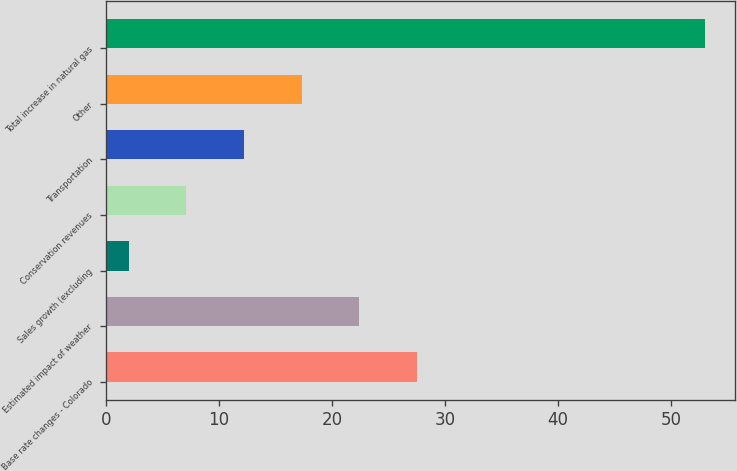Convert chart to OTSL. <chart><loc_0><loc_0><loc_500><loc_500><bar_chart><fcel>Base rate changes - Colorado<fcel>Estimated impact of weather<fcel>Sales growth (excluding<fcel>Conservation revenues<fcel>Transportation<fcel>Other<fcel>Total increase in natural gas<nl><fcel>27.5<fcel>22.4<fcel>2<fcel>7.1<fcel>12.2<fcel>17.3<fcel>53<nl></chart> 